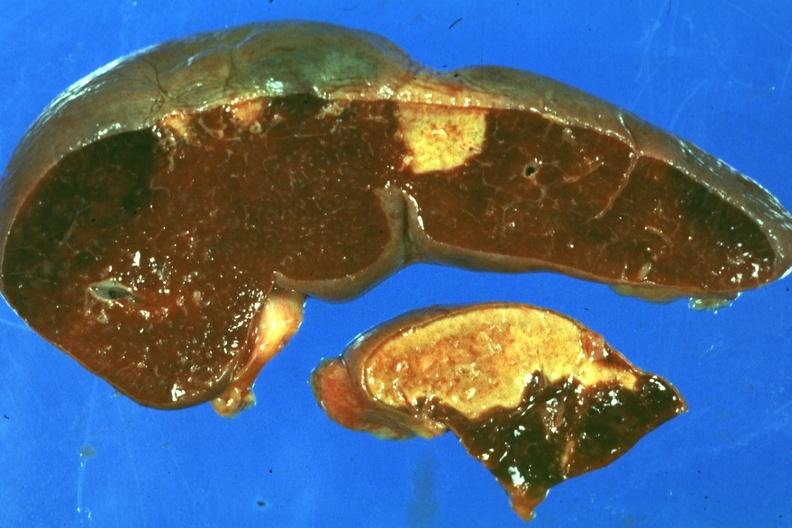what is present?
Answer the question using a single word or phrase. Infarct 